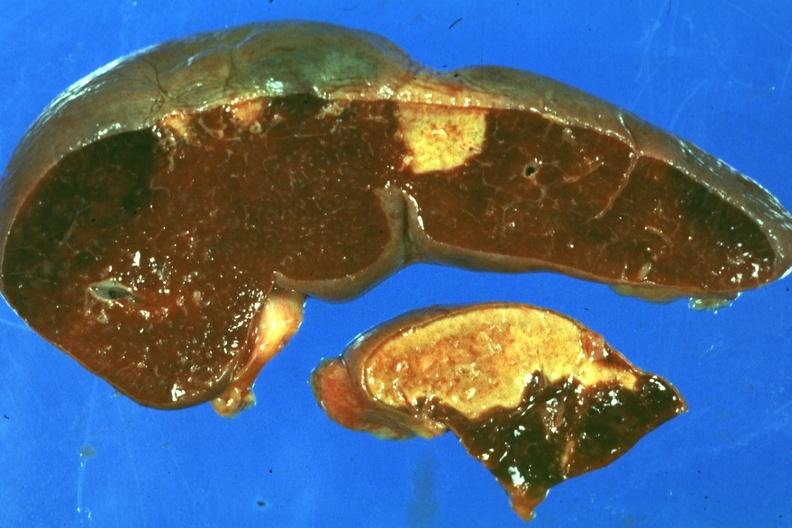what is present?
Answer the question using a single word or phrase. Infarct 